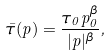Convert formula to latex. <formula><loc_0><loc_0><loc_500><loc_500>\bar { \tau } ( p ) = \frac { \tau _ { 0 } p _ { 0 } ^ { \beta } } { | p | ^ { \beta } } ,</formula> 